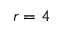Convert formula to latex. <formula><loc_0><loc_0><loc_500><loc_500>r = 4</formula> 